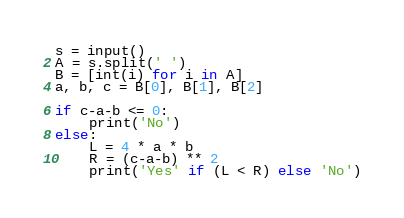Convert code to text. <code><loc_0><loc_0><loc_500><loc_500><_Python_>s = input()
A = s.split(' ')
B = [int(i) for i in A]
a, b, c = B[0], B[1], B[2]

if c-a-b <= 0:
    print('No')
else:
    L = 4 * a * b
    R = (c-a-b) ** 2
    print('Yes' if (L < R) else 'No')
</code> 